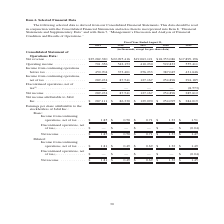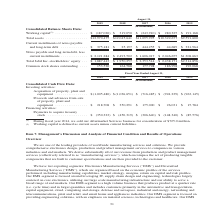According to Jabil Circuit's financial document, How does the company define working capital? current assets minus current liabilities. The document states: "$725.0 million. (2) Working capital is defined as current assets minus current liabilities...." Also, What were the total assets in 2019? According to the financial document, $12,970,475 (in thousands). The relevant text states: "Total assets . $12,970,475 $12,045,641 $11,095,995 $10,322,677 $9,591,600..." Also, What are the years included in the table? The document contains multiple relevant values: 2019, 2018, 2017, 2016, 2015. From the document: "2019 2018 2017 2016 2015 2019 2018 2017 2016 2015 2019 2018 2017 2016 2015 2019 2018 2017 2016 2015 2019 2018 2017 2016 2015..." Also, can you calculate: What was the change in Current installments of notes payable and long-term debt between 2018 and 2019? Based on the calculation: $375,181-$25,197, the result is 349984 (in thousands). This is based on the information: "of notes payable and long-term debt . $ 375,181 $ 25,197 $ 444,255 $ 44,689 $ 321,964 tallments of notes payable and long-term debt . $ 375,181 $ 25,197 $ 444,255 $ 44,689 $ 321,964..." The key data points involved are: 25,197, 375,181. Also, How many years did Common stock shares outstanding exceed $160,000 thousand? Counting the relevant items in the document: 2018, 2017, 2016, 2015, I find 4 instances. The key data points involved are: 2015, 2016, 2017. Also, can you calculate: What was the percentage change in Total Jabil Inc. stockholders’ equity between 2018 and 2019? To answer this question, I need to perform calculations using the financial data. The calculation is: (1,887,443-1,950,257)/1,950,257, which equals -3.22 (percentage). This is based on the information: "Total Jabil Inc. stockholders’ equity . $ 1,887,443 $ 1,950,257 $ 2,353,514 $ 2,438,171 $2,314,856 l Jabil Inc. stockholders’ equity . $ 1,887,443 $ 1,950,257 $ 2,353,514 $ 2,438,171 $2,314,856..." The key data points involved are: 1,887,443, 1,950,257. 